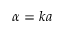<formula> <loc_0><loc_0><loc_500><loc_500>\alpha = k a</formula> 